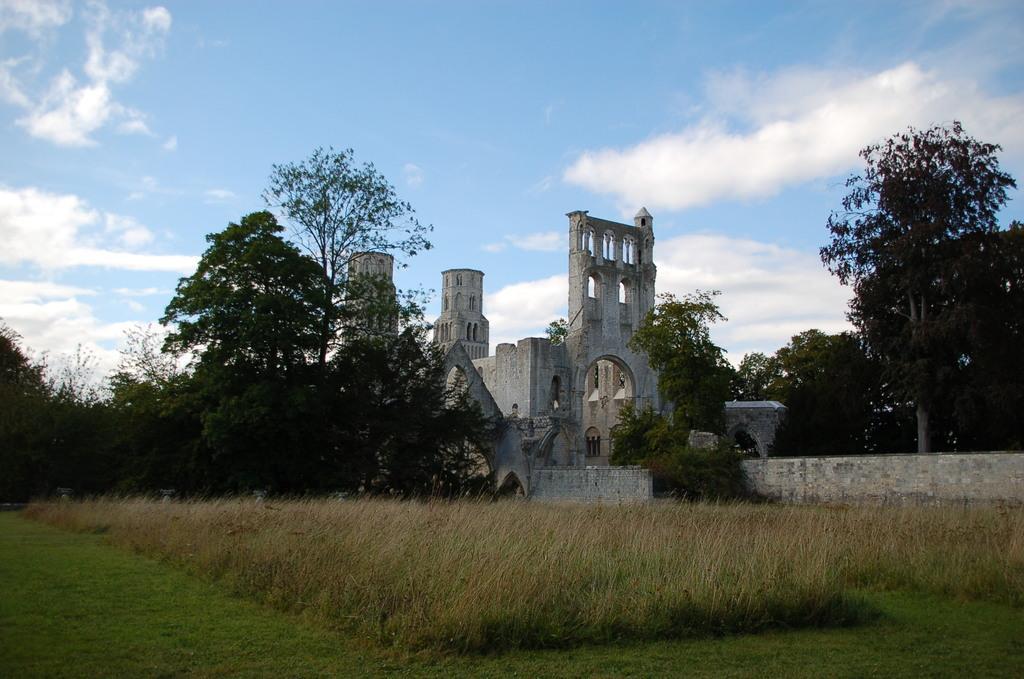How would you summarize this image in a sentence or two? In this image we can see a building. We can also see a wall, a group of trees, some plants, grass and the sky which looks cloudy. 